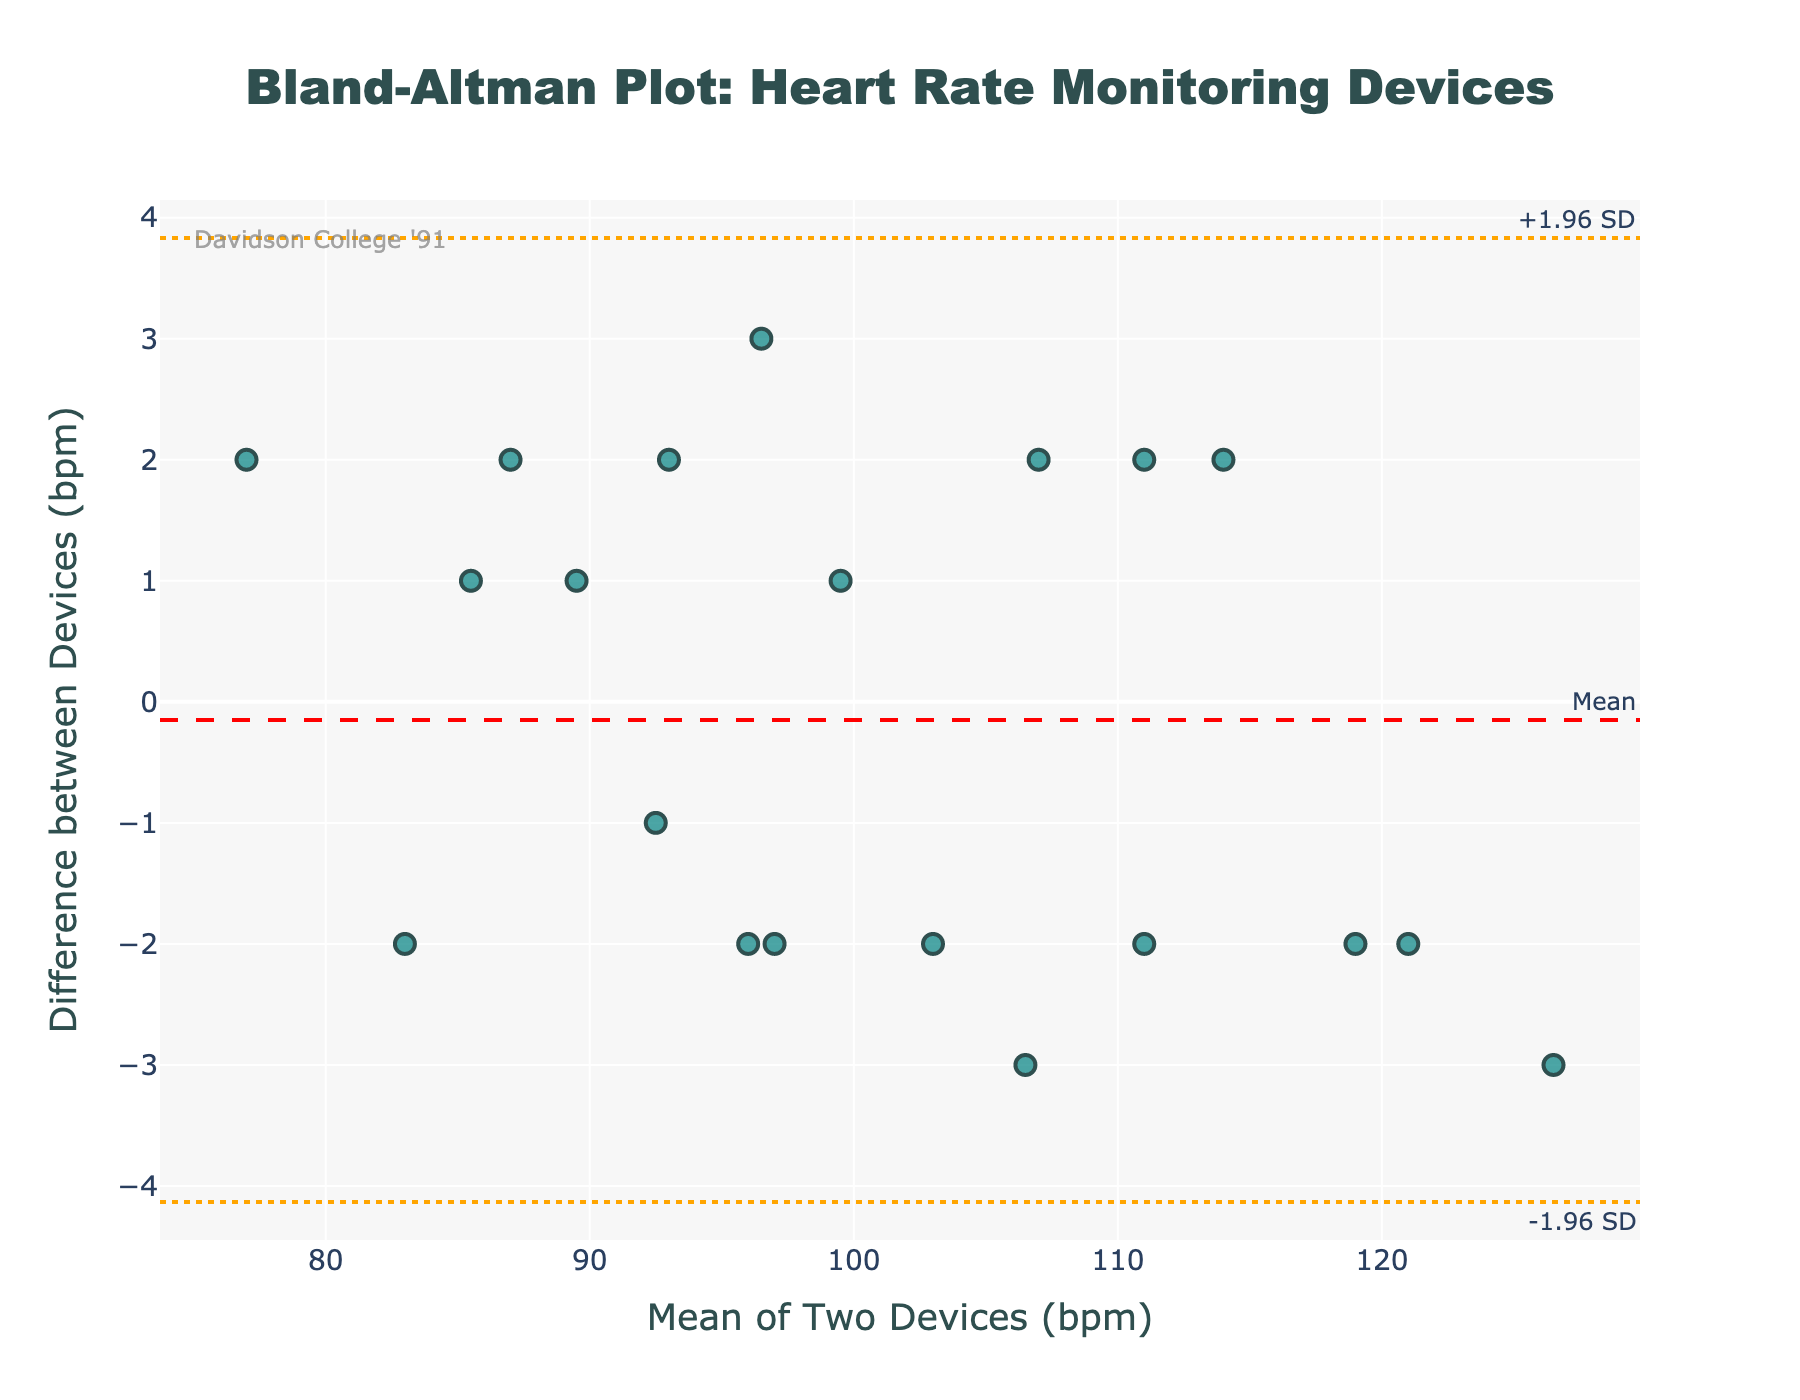How many data points are plotted on the Bland-Altman plot? Count the number of markers on the plot. In the code, we know there are 20 data points.
Answer: 20 What does the red dashed line represent? The red dashed line is labeled "Mean," referring to the mean difference between the heart rate readings of the two devices.
Answer: Mean difference What are the values of the upper and lower limits of agreement? The orange dotted lines labeled "+1.96 SD" and "-1.96 SD" represent the upper and lower limits of agreement. You can directly see their values on the y-axis where these lines intersect.
Answer: Upper: 2.9, Lower: -2.6 What is the range of the mean heart rate values plotted on the x-axis? The x-axis shows the mean heart rate values, ranging approximately from 77 bpm to 126 bpm. This can be observed by checking the minimum and maximum x-axis ticks.
Answer: 77 to 126 bpm Are most of the differences between device readings within the limits of agreement? By observing the markers, most fall between the upper and lower limits of agreement lines, indicating that the differences are generally within the acceptable range.
Answer: Yes What is the mean difference between the two devices? The mean difference is represented by the red dashed line and its y-intercept value, visible on the plot.
Answer: 0.15 bpm Are there any obvious outliers in the dataset? By looking for points far outside the limits of agreement, we can see if outliers exist. On this plot, no points are far above the upper or below the lower limits of agreement.
Answer: No What does the spread of points around the mean difference indicate about the two devices? The spread represents the variability in differences between the devices' measurements. A smaller spread suggests more agreement, while a larger spread indicates more variability.
Answer: Low variability What is the mean heart rate value where the greatest difference between devices is observed? Look for the point with the largest vertical distance from the mean difference line and note its x-axis mean heart rate value.
Answer: ~116 bpm How does the difference vary with increased heart rate mean values? By observing the distribution of points, one can see whether the differences increase or decrease as mean heart rate values go up. In this case, differences seem fairly consistent across the range.
Answer: Fairly consistent 